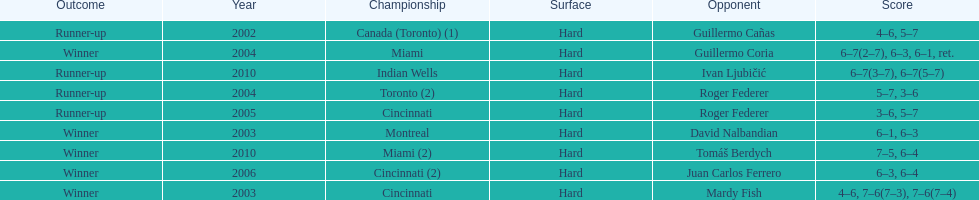What was the highest number of consecutive wins? 3. 